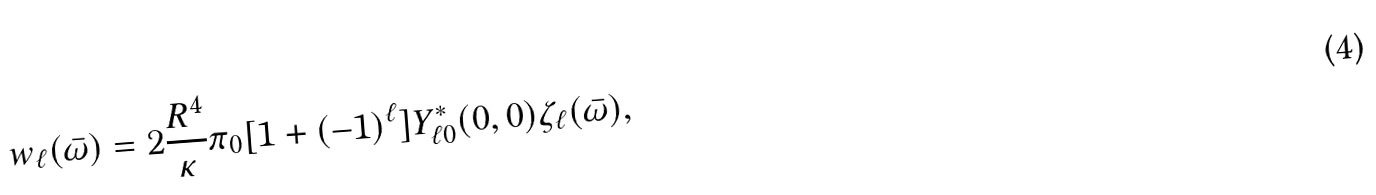<formula> <loc_0><loc_0><loc_500><loc_500>w _ { \ell } ( \bar { \omega } ) = 2 \frac { R ^ { 4 } } { \kappa } \pi _ { 0 } [ 1 + ( - 1 ) ^ { \ell } ] Y ^ { * } _ { \ell 0 } ( 0 , 0 ) \zeta _ { \ell } ( \bar { \omega } ) ,</formula> 